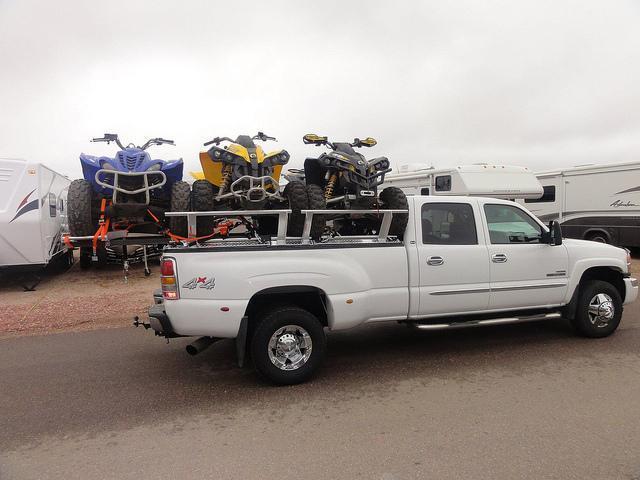How many four wheelers are there?
Give a very brief answer. 3. How many vehicles in picture are white?
Give a very brief answer. 4. How many vehicles are shown?
Give a very brief answer. 7. How many motorcycles can be seen?
Give a very brief answer. 2. How many people are wearing a hat?
Give a very brief answer. 0. 